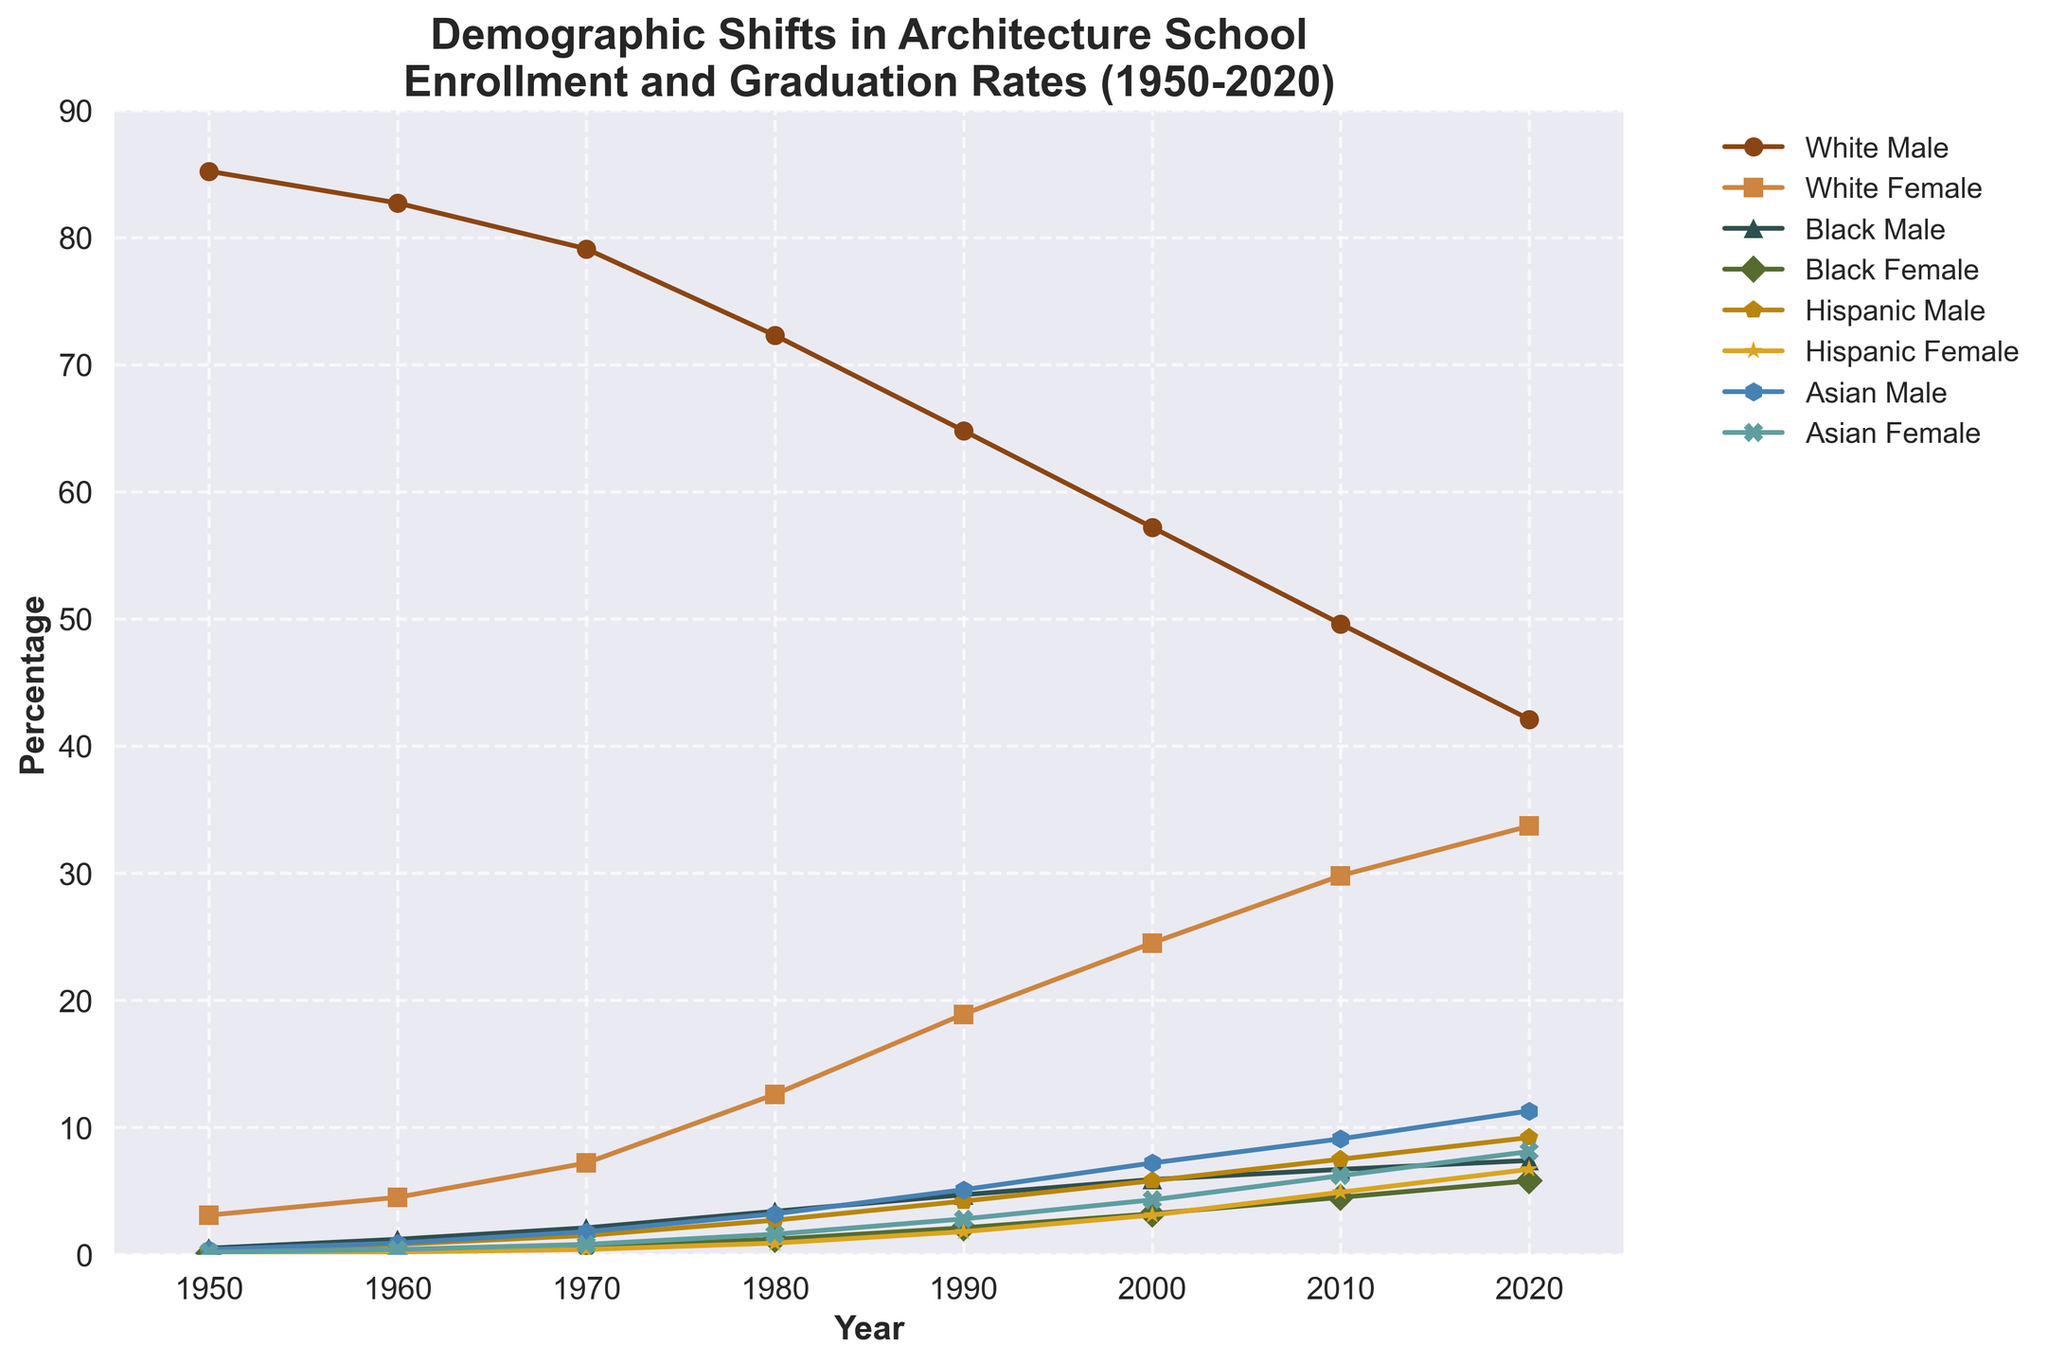What was the percentage change in enrollment for White Males from 1950 to 2020? To find the percentage change, subtract the percentage in 1950 from the percentage in 2020 and then divide by the percentage in 1950. Multiply by 100 for the percentage. (42.1 - 85.2) / 85.2 * 100 = -50.6%
Answer: -50.6% Which demographic group saw the highest increase in enrollment from 1950 to 2020? To find the highest increase, calculate the difference between 1950 and 2020 for each group and compare the results. For Asian Male: 11.3 - 0.4 = 10.9. This process is repeated for all groups, then the highest value is determined.
Answer: Asian Male In what year did the percentage of White Females first surpass 20%? By examining the line for White Female, we see that it first surpasses 20% in the year indicated on the x-axis. The value surpasses 20% in 2000.
Answer: 2000 What is the combined percentage of Black Male and Black Female in 1980? Add the percentage for Black Male and Black Female in 1980 together. 3.4 + 1.2 = 4.6
Answer: 4.6 Which two groups had the closest enrollment percentages in 2020? Compare the percentages for all groups in 2020 to find the two closest values. The closest values are White Female (33.7) and Hispanic Male (33.7 - 9.2 = 24.5, but closer gap is 33.7 - 42.1 for White Males). Either side by side comparison may show closest groups might be Hispanic Female and Asian Female.
Answer: Hispanic Female and Asian Female How did the Hispanic Female enrollment change from 1960 to 2000? Subtract the percentage in 1960 from the percentage in 2000: 3.1 - 0.2 = 2.9
Answer: 2.9 What is the visual trend observed for Asian Females from 1950 to 2020? The line corresponding to Asian Females can be followed from 1950 to 2020. The visual trend shows a consistent upward trajectory starting from a very low point near zero and increasing steadily to 8.1% by 2020.
Answer: Increasing Trend In which year did Hispanic Male enrollment surpass Asian Male enrollment for the first time? Compare the two lines representing Hispanic Male and Asian Male. The intersection point first appears in 1990.
Answer: 1990 Which ethnicity and gender had the lowest enrollment in 1950? Look at all the starting points for 1950 and identify the lowest value on the y-axis. Black Female has the lowest enrollment at 0.1%.
Answer: Black Female What was the difference in percentage enrollment between White Females and White Males in 2020? Subtract the percentage of White Females from the percentage of White Males in 2020. 42.1 - 33.7 = 8.4
Answer: 8.4 